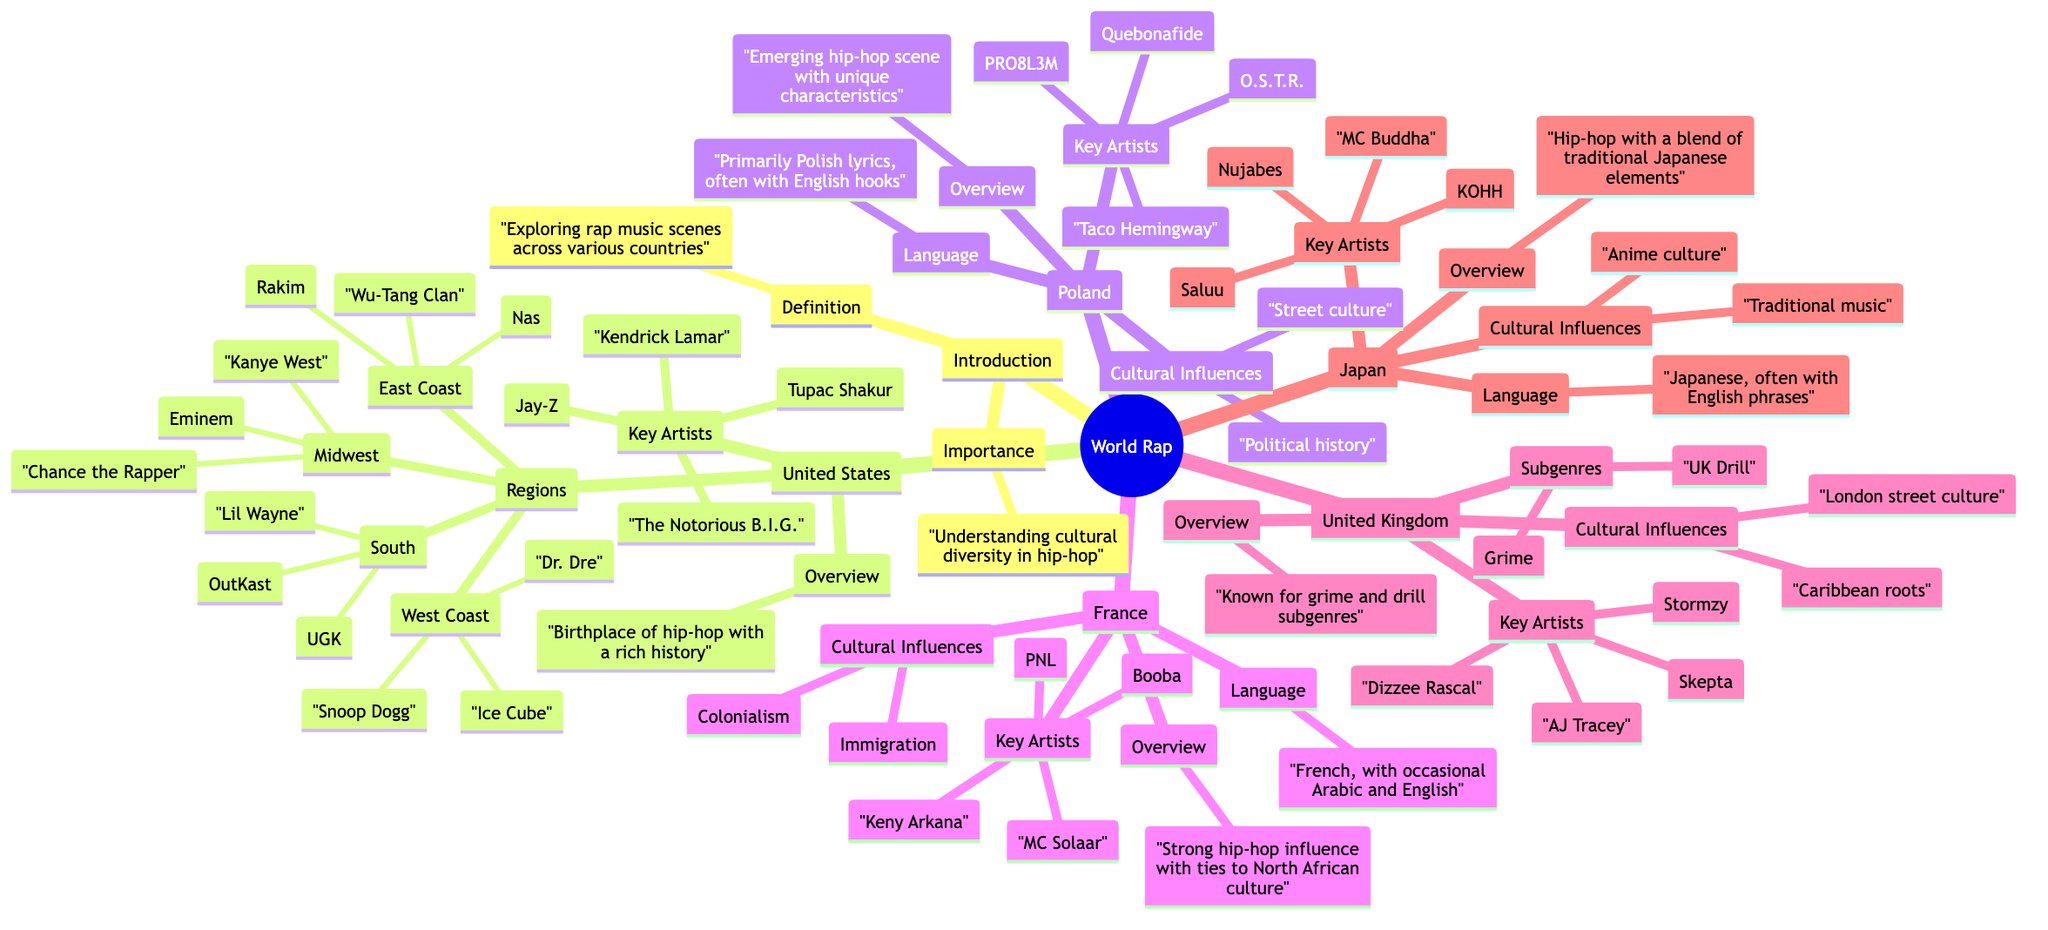What defines "World Rap"? The node labeled "Definition" states that "World Rap" is about exploring rap music scenes across various countries. This provides a clear definition of the overall concept.
Answer: Exploring rap music scenes across various countries How many regions are listed under the United States? In the diagram, the "Regions" node under "United States" contains four distinct regions: East Coast, West Coast, South, and Midwest. Counting these gives us the total.
Answer: 4 Who is a key artist from Poland? The "Key Artists" node under the "Poland" section lists several artists, one of which is "Taco Hemingway". This answers the question about key artists in that specific region.
Answer: Taco Hemingway What cultural influences are noted for the UK rap scene? In the "Cultural Influences" node under "United Kingdom", it mentions "London street culture" and "Caribbean roots", thus combining these two elements gives us the influences.
Answer: London street culture, Caribbean roots Which language is primarily used in Polish lyrics? The "Language" node under "Poland" specifies that the language is "Primarily Polish lyrics, often with English hooks". This clearly answers the language usage in Polish rap.
Answer: Primarily Polish lyrics, often with English hooks Who is a key artist associated with Japanese hip-hop? The "Key Artists" node under "Japan" lists names including "Nujabes". This directly answers the question regarding key figures in the Japanese hip-hop scene.
Answer: Nujabes What subgenres are identified in the UK rap scene? The "Subgenres" node lists "Grime" and "UK Drill", indicating the specific subgenres that are prevalent in UK rap. This directly answers the inquiry.
Answer: Grime, UK Drill What is the main cultural influence on French hip-hop? Under the "Cultural Influences" node for "France", it lists "Colonialism" and "Immigration". This helps identify key influences in the cultural and historical context of French rap.
Answer: Colonialism, Immigration How many key artists are mentioned for the United States? The "Key Artists" node under "United States" includes four names: Tupac Shakur, The Notorious B.I.G., Jay-Z, and Kendrick Lamar. Counting these gives the total number of key artists mentioned.
Answer: 4 